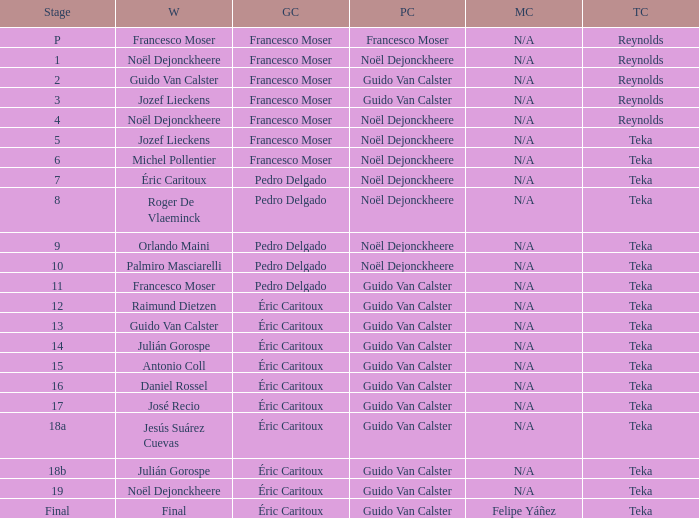Name the points classification for stage of 18b Guido Van Calster. 